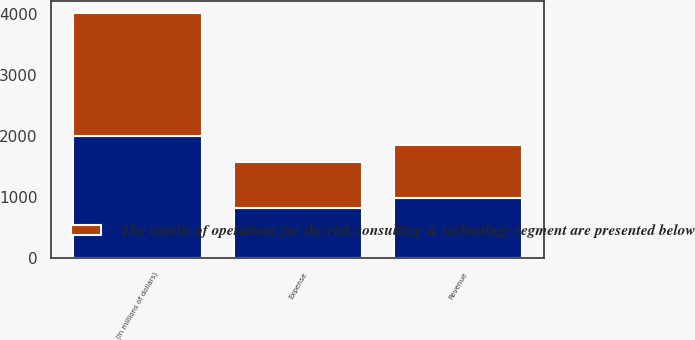Convert chart. <chart><loc_0><loc_0><loc_500><loc_500><stacked_bar_chart><ecel><fcel>(In millions of dollars)<fcel>Revenue<fcel>Expense<nl><fcel>nan<fcel>2006<fcel>979<fcel>830<nl><fcel>The results of operations for the risk consulting & technology segment are presented below<fcel>2005<fcel>872<fcel>751<nl></chart> 